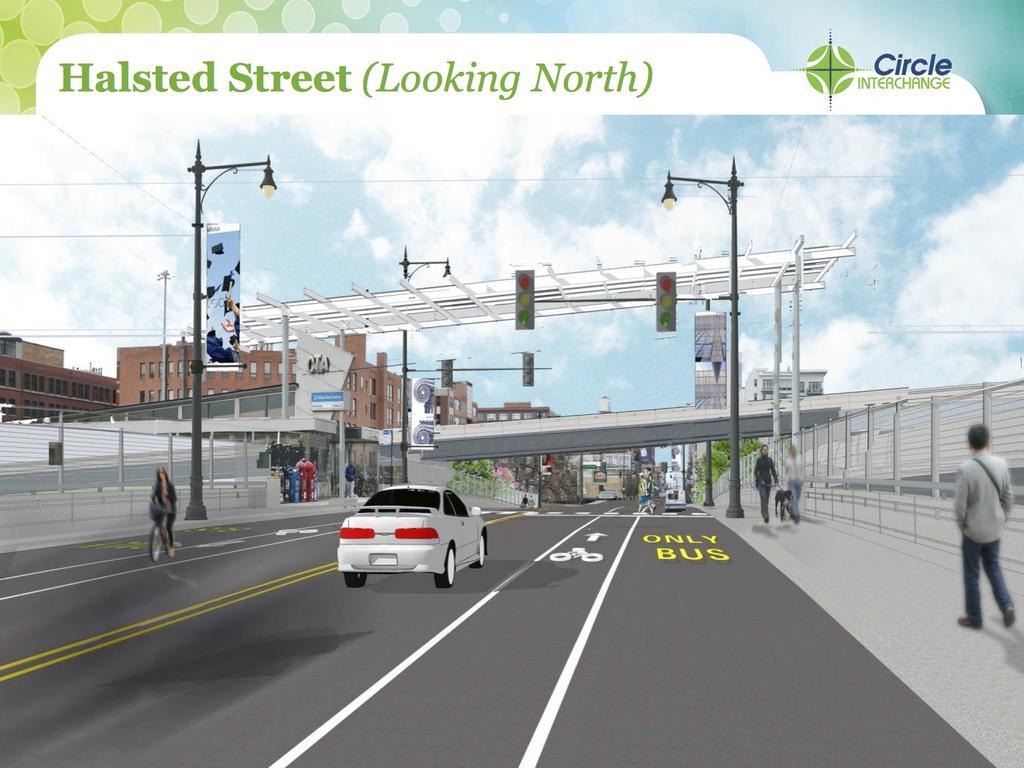Describe this image in one or two sentences. In this image we can see a car on the road and there are people. On the left there is a person riding a bicycle. In the background there are buildings, poles, boards, trees and sky. We can see wires. 